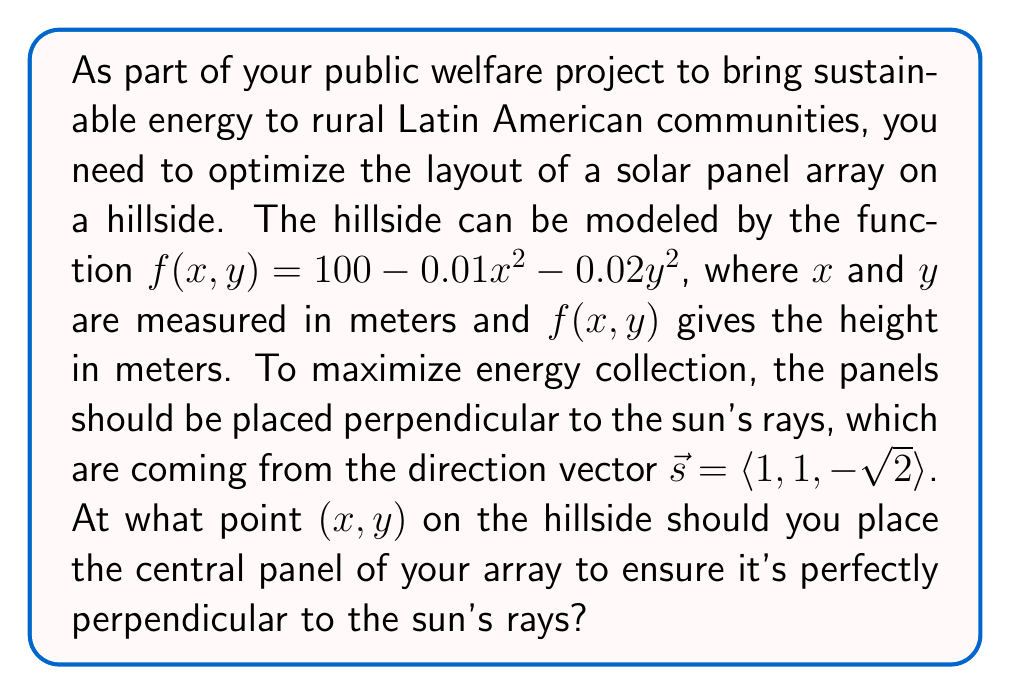Solve this math problem. To solve this problem, we'll follow these steps:

1) First, we need to find the normal vector to the surface at any point $(x,y)$. This can be done by calculating the gradient of $f(x,y)$:

   $$\nabla f = \left\langle \frac{\partial f}{\partial x}, \frac{\partial f}{\partial y}, -1 \right\rangle = \langle -0.02x, -0.04y, -1 \rangle$$

2) For the panel to be perpendicular to the sun's rays, the normal vector of the surface must be parallel (or anti-parallel) to the sun's direction vector. This means they must be scalar multiples of each other:

   $$k\langle -0.02x, -0.04y, -1 \rangle = \langle 1, 1, -\sqrt{2} \rangle$$

   where $k$ is some scalar.

3) This gives us a system of equations:

   $$-0.02kx = 1$$
   $$-0.04ky = 1$$
   $$-k = -\sqrt{2}$$

4) From the last equation, we can determine $k = \sqrt{2}$.

5) Substituting this back into the first two equations:

   $$-0.02\sqrt{2}x = 1$$
   $$-0.04\sqrt{2}y = 1$$

6) Solving these:

   $$x = -\frac{1}{0.02\sqrt{2}} = -35.36$$
   $$y = -\frac{1}{0.04\sqrt{2}} = -17.68$$

7) Therefore, the point where the central panel should be placed is approximately $(-35.36, -17.68)$.

8) We can verify this by checking that the normal vector at this point is indeed parallel to the sun's direction vector:

   $$\nabla f(-35.36, -17.68) = \langle 0.7072, 0.7072, -1 \rangle$$

   which is indeed parallel to $\langle 1, 1, -\sqrt{2} \rangle$.
Answer: $(-35.36, -17.68)$ 